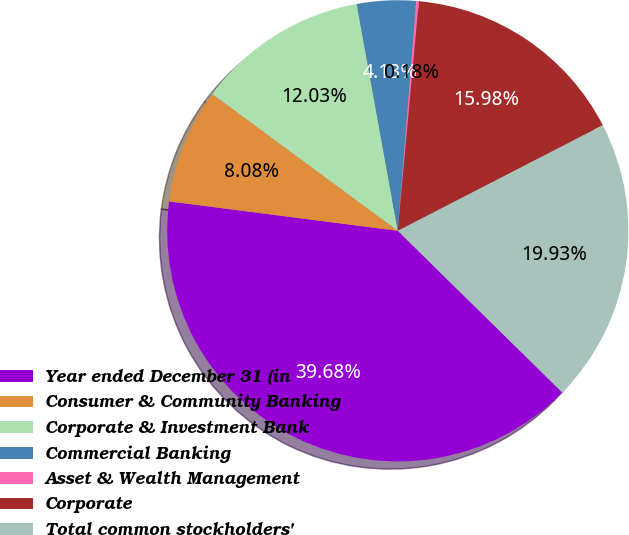Convert chart. <chart><loc_0><loc_0><loc_500><loc_500><pie_chart><fcel>Year ended December 31 (in<fcel>Consumer & Community Banking<fcel>Corporate & Investment Bank<fcel>Commercial Banking<fcel>Asset & Wealth Management<fcel>Corporate<fcel>Total common stockholders'<nl><fcel>39.68%<fcel>8.08%<fcel>12.03%<fcel>4.13%<fcel>0.18%<fcel>15.98%<fcel>19.93%<nl></chart> 